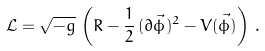<formula> <loc_0><loc_0><loc_500><loc_500>\mathcal { L } = \sqrt { - g } \, \left ( R - \frac { 1 } { 2 } \, ( \partial \vec { \phi } ) ^ { 2 } - V \vec { ( \phi ) } \right ) \, .</formula> 